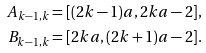<formula> <loc_0><loc_0><loc_500><loc_500>A _ { k - 1 , k } & = [ ( 2 k - 1 ) a , 2 k a - 2 ] , \\ B _ { k - 1 , k } & = [ 2 k a , ( 2 k + 1 ) a - 2 ] .</formula> 